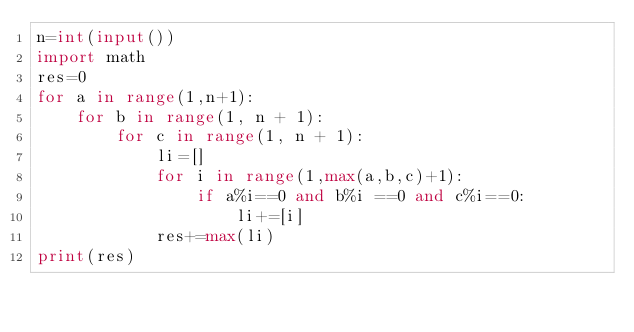<code> <loc_0><loc_0><loc_500><loc_500><_Python_>n=int(input())
import math
res=0
for a in range(1,n+1):
    for b in range(1, n + 1):
        for c in range(1, n + 1):
            li=[]
            for i in range(1,max(a,b,c)+1):
                if a%i==0 and b%i ==0 and c%i==0:
                    li+=[i]
            res+=max(li)
print(res)</code> 